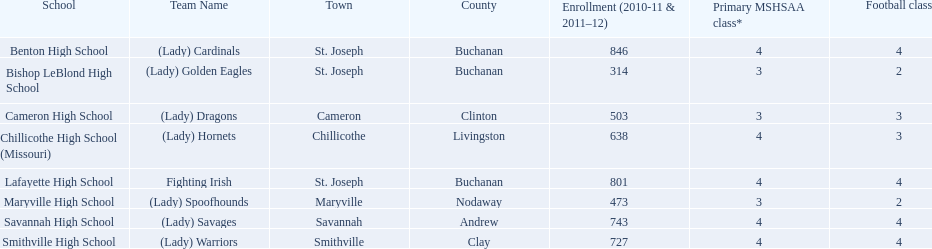What are the names of the schools? Benton High School, Bishop LeBlond High School, Cameron High School, Chillicothe High School (Missouri), Lafayette High School, Maryville High School, Savannah High School, Smithville High School. Of those, which had a total enrollment of less than 500? Bishop LeBlond High School, Maryville High School. And of those, which had the lowest enrollment? Bishop LeBlond High School. 